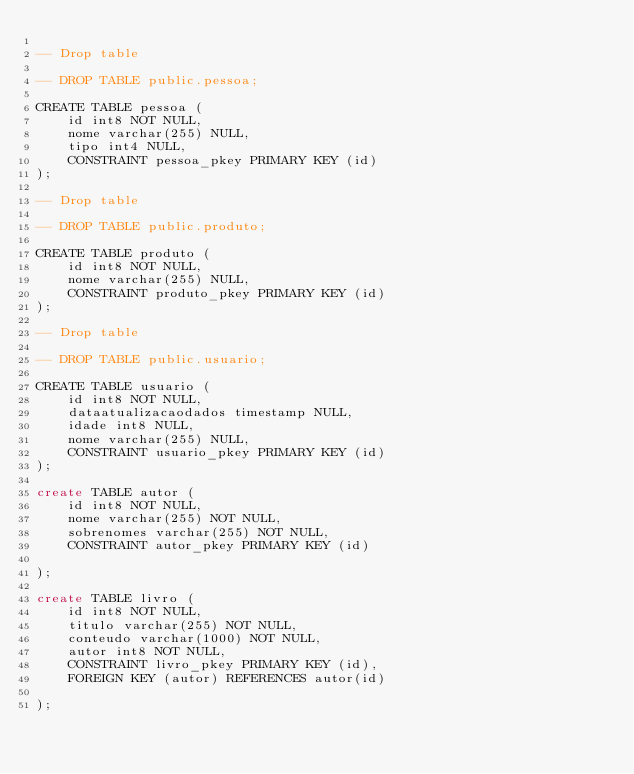Convert code to text. <code><loc_0><loc_0><loc_500><loc_500><_SQL_>
-- Drop table

-- DROP TABLE public.pessoa;

CREATE TABLE pessoa (
	id int8 NOT NULL,
	nome varchar(255) NULL,
	tipo int4 NULL,
	CONSTRAINT pessoa_pkey PRIMARY KEY (id)
);

-- Drop table

-- DROP TABLE public.produto;

CREATE TABLE produto (
	id int8 NOT NULL,
	nome varchar(255) NULL,
	CONSTRAINT produto_pkey PRIMARY KEY (id)
);

-- Drop table

-- DROP TABLE public.usuario;

CREATE TABLE usuario (
	id int8 NOT NULL,
	dataatualizacaodados timestamp NULL,
	idade int8 NULL,
	nome varchar(255) NULL,
	CONSTRAINT usuario_pkey PRIMARY KEY (id)
);

create TABLE autor (
	id int8 NOT NULL,
	nome varchar(255) NOT NULL,
	sobrenomes varchar(255) NOT NULL,
	CONSTRAINT autor_pkey PRIMARY KEY (id)

);

create TABLE livro (
	id int8 NOT NULL,
	titulo varchar(255) NOT NULL,
	conteudo varchar(1000) NOT NULL,
	autor int8 NOT NULL,
	CONSTRAINT livro_pkey PRIMARY KEY (id),
	FOREIGN KEY (autor) REFERENCES autor(id)

);

</code> 